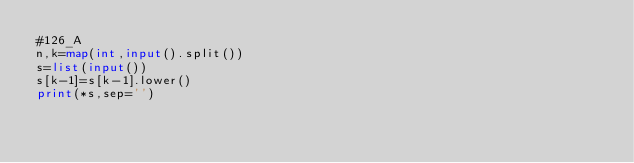Convert code to text. <code><loc_0><loc_0><loc_500><loc_500><_Python_>#126_A
n,k=map(int,input().split())
s=list(input())
s[k-1]=s[k-1].lower()
print(*s,sep='')</code> 